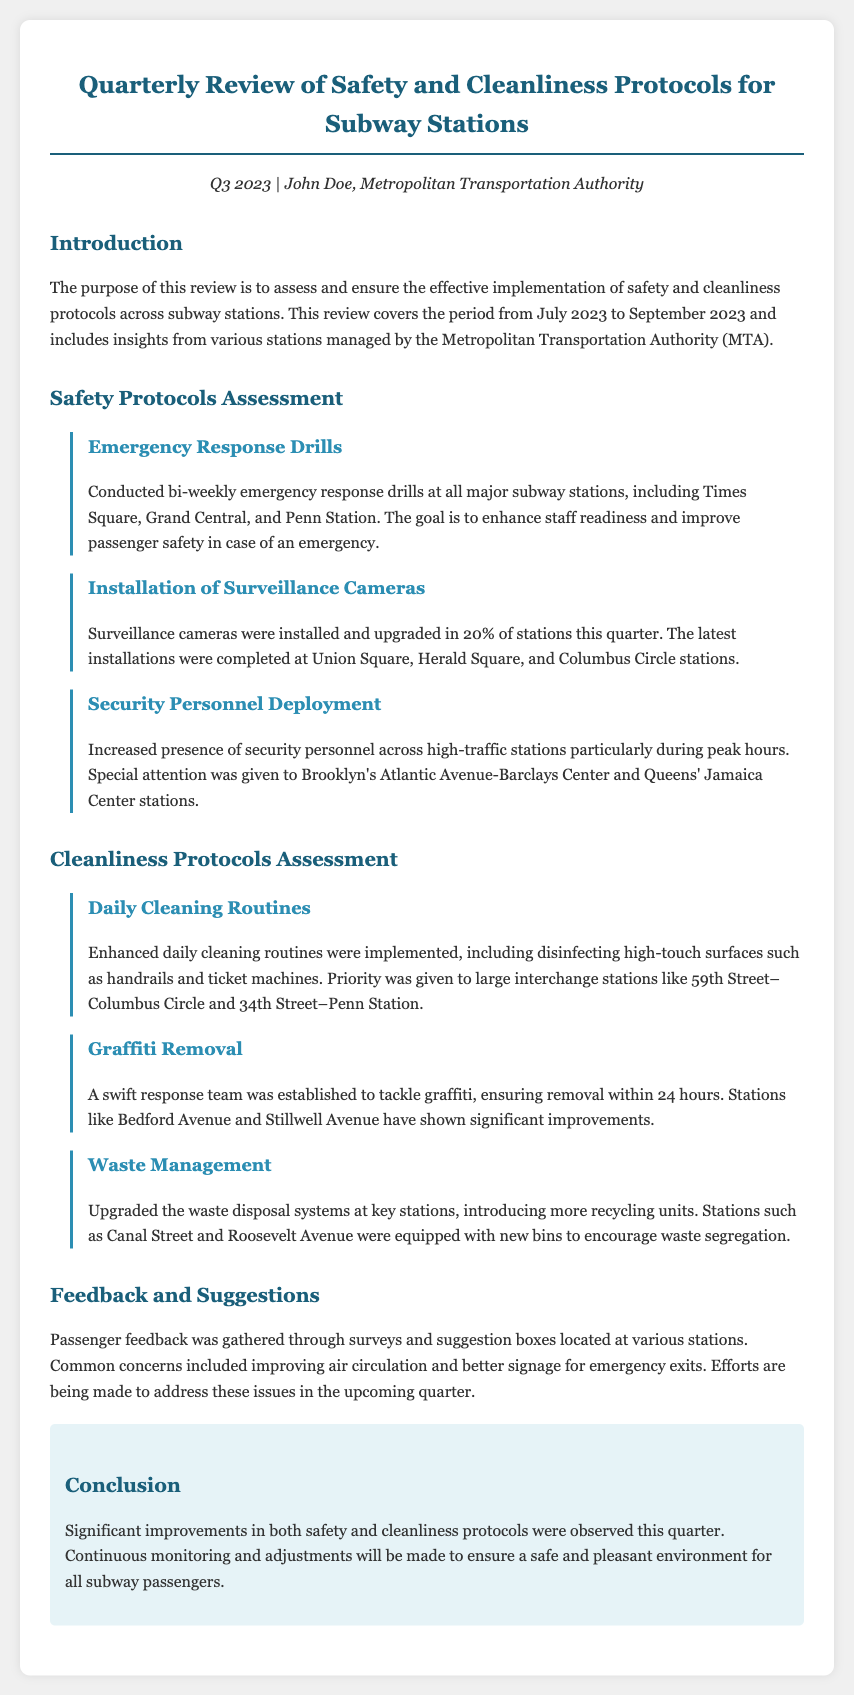what was the review period? The review covers the period from July 2023 to September 2023.
Answer: July 2023 to September 2023 how often were emergency response drills conducted? Emergency response drills were conducted bi-weekly.
Answer: bi-weekly which stations had surveillance camera installations this quarter? The latest installations were completed at Union Square, Herald Square, and Columbus Circle.
Answer: Union Square, Herald Square, and Columbus Circle what specific cleaning routine was enhanced? Enhanced daily cleaning routines were implemented, including disinfecting high-touch surfaces.
Answer: disinfecting high-touch surfaces what was a common concern mentioned in the passenger feedback? Common concerns included improving air circulation and better signage for emergency exits.
Answer: improving air circulation which stations upgraded their waste disposal systems? Stations such as Canal Street and Roosevelt Avenue were equipped with new bins.
Answer: Canal Street and Roosevelt Avenue what actions were taken regarding graffiti? A swift response team was established to tackle graffiti.
Answer: swift response team what is the overall conclusion regarding safety and cleanliness? Significant improvements in both safety and cleanliness protocols were observed this quarter.
Answer: Significant improvements in both safety and cleanliness protocols 